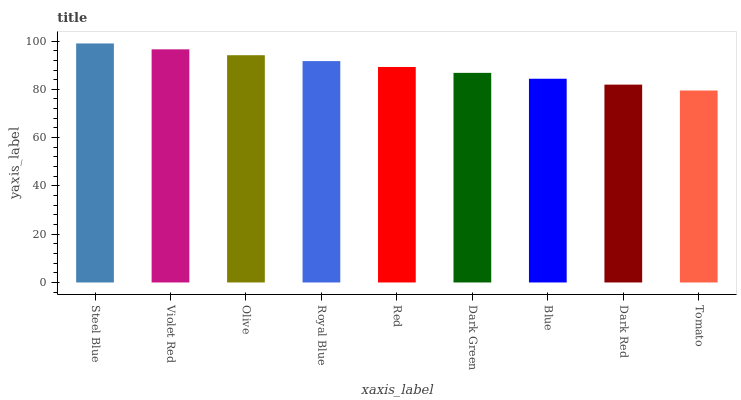Is Tomato the minimum?
Answer yes or no. Yes. Is Steel Blue the maximum?
Answer yes or no. Yes. Is Violet Red the minimum?
Answer yes or no. No. Is Violet Red the maximum?
Answer yes or no. No. Is Steel Blue greater than Violet Red?
Answer yes or no. Yes. Is Violet Red less than Steel Blue?
Answer yes or no. Yes. Is Violet Red greater than Steel Blue?
Answer yes or no. No. Is Steel Blue less than Violet Red?
Answer yes or no. No. Is Red the high median?
Answer yes or no. Yes. Is Red the low median?
Answer yes or no. Yes. Is Tomato the high median?
Answer yes or no. No. Is Violet Red the low median?
Answer yes or no. No. 